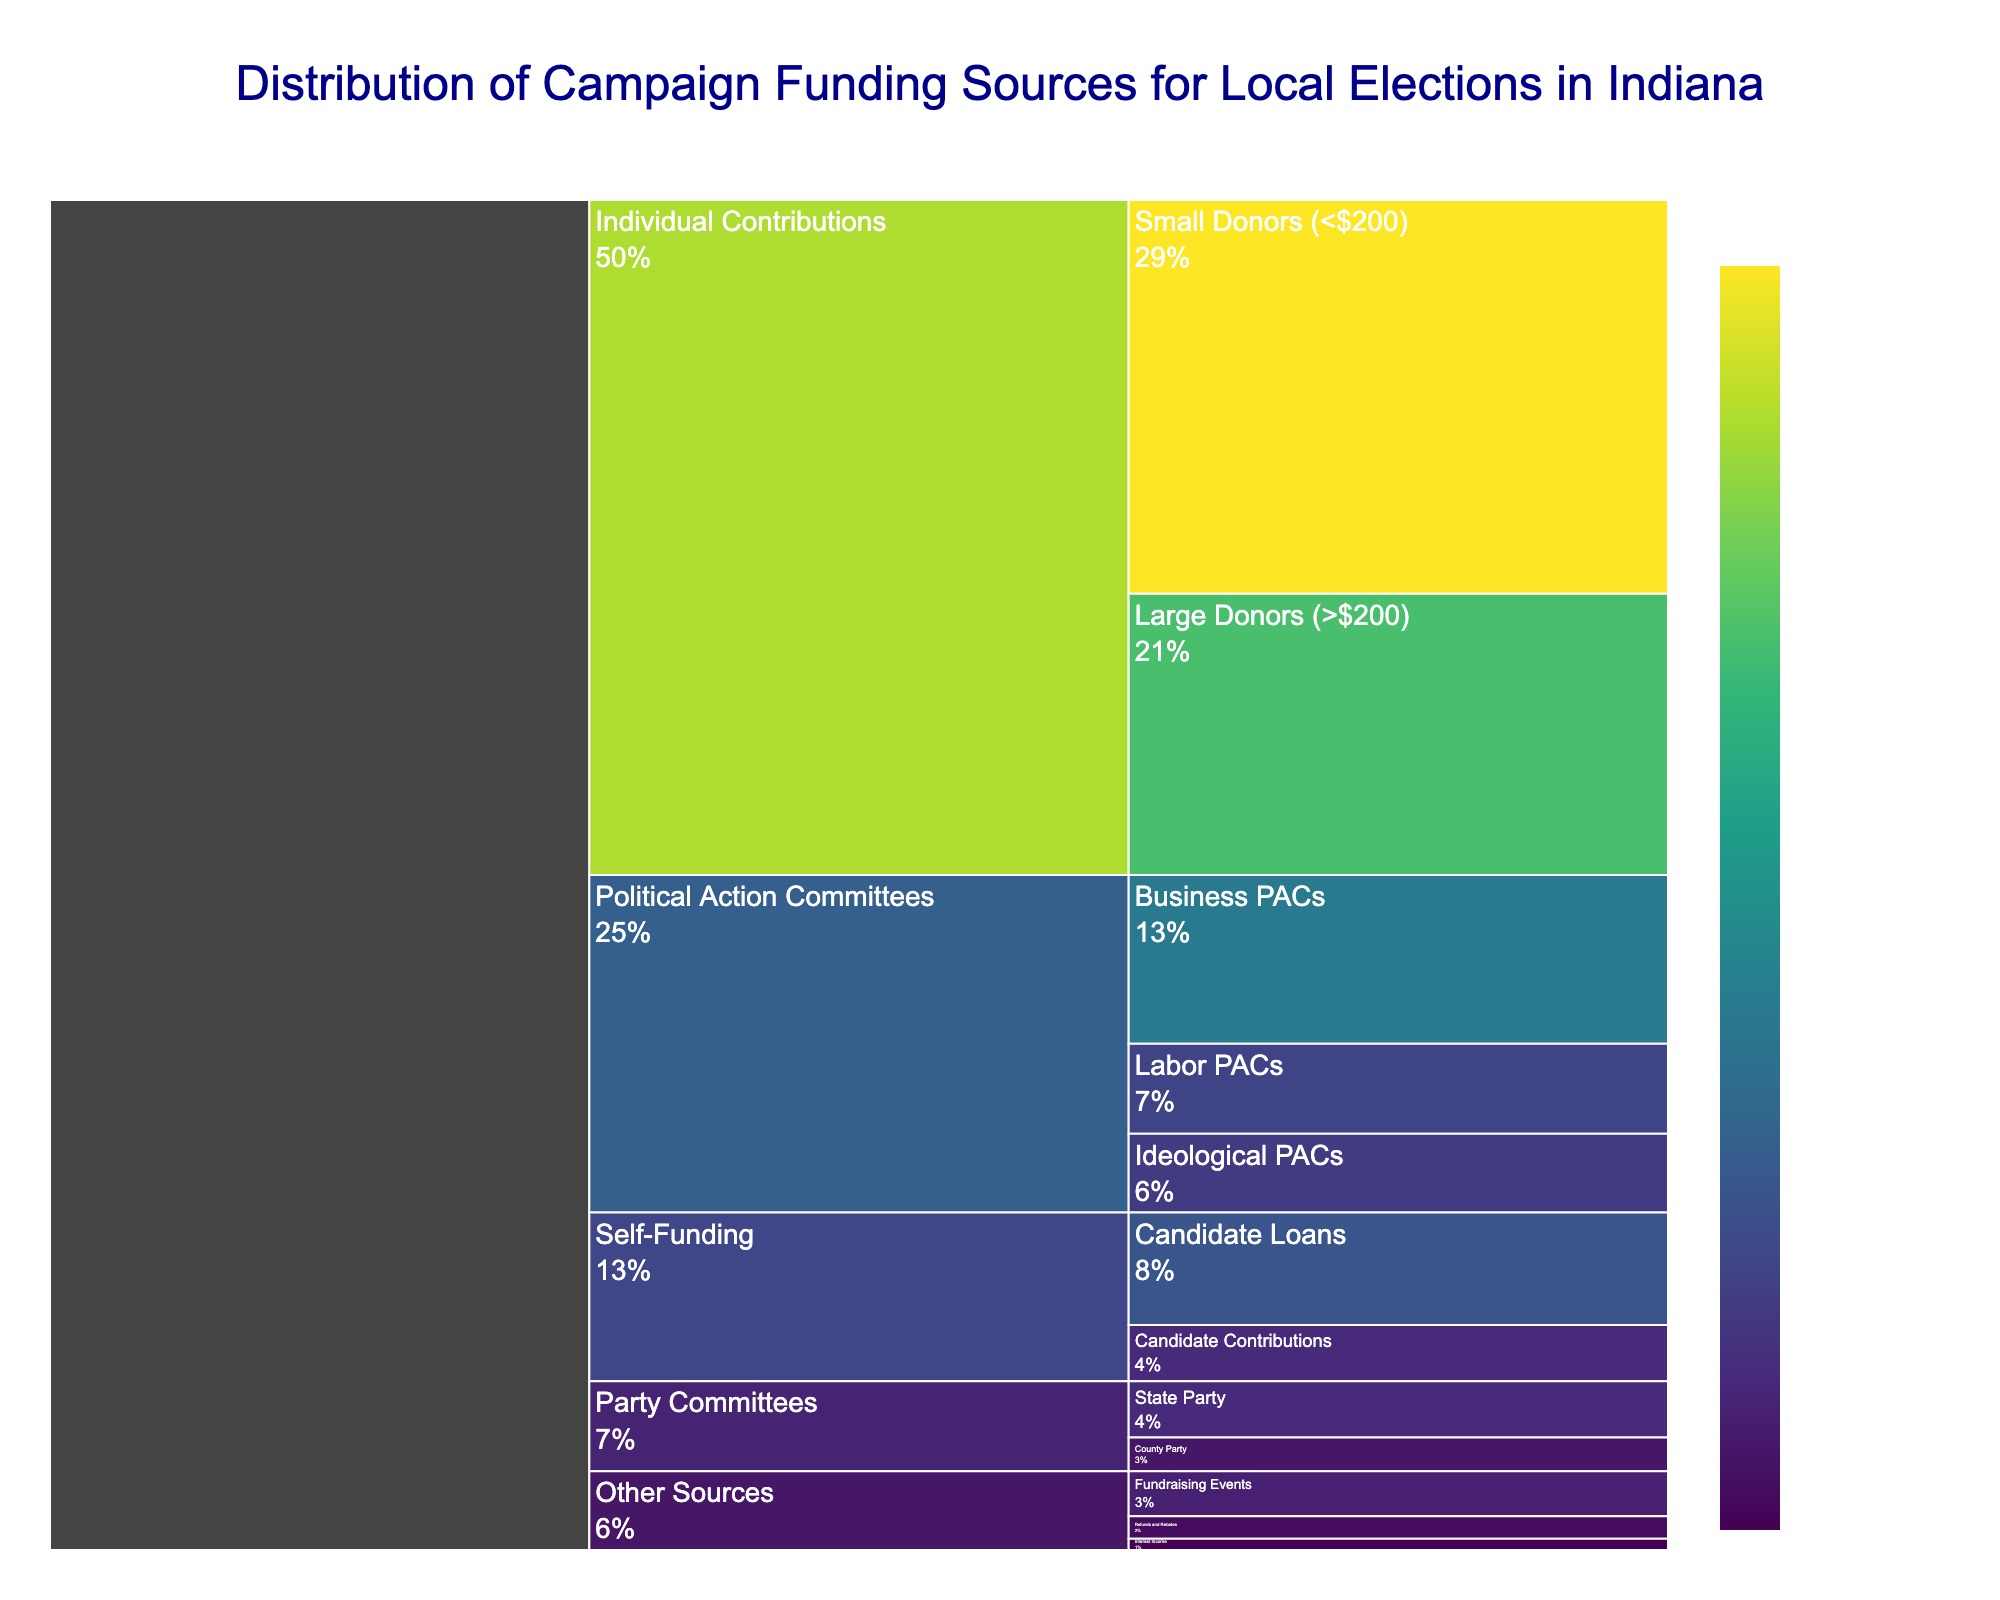What is the title of the icicle chart? The title of the chart is displayed prominently at the top of the figure in a large, dark blue font.
Answer: Distribution of Campaign Funding Sources for Local Elections in Indiana Which funding source category has the largest contribution value? By observing the sizes of the sections in the icicle chart, the category with the largest contribution value stands out.
Answer: Individual Contributions What is the combined contribution value of the Political Action Committees category? Sum the values of Business PACs (15), Labor PACs (8), and Ideological PACs (7) within the Political Action Committees category.
Answer: 30 Compare the contributions from Individual Contributions and Self-Funding categories. Which one is higher and by how much? Individual Contributions total 35 + 25 = 60, and Self-Funding totals 10 + 5 = 15. Subtract the Self-Funding value from the Individual Contributions value to find the difference. 60 - 15 = 45.
Answer: Individual Contributions is higher by 45 What percentage of the total funding does the State Party represent within the Party Committees category? First, sum the contributions under Party Committees (State Party: 5, County Party: 3, total=8). Then, calculate the percentage for State Party: (5 / 8) * 100 = 62.5%.
Answer: 62.5% Which subcategory within Other Sources has the smallest contribution value? Review the values of subcategories under Other Sources (Fundraising Events: 4, Interest Income: 1, Refunds and Rebates: 2) and identify the smallest value.
Answer: Interest Income What is the total contribution value from all categories combined? Sum the values of all the contributions across all categories. 35 + 25 + 15 + 8 + 7 + 5 + 3 + 10 + 5 + 4 + 1 + 2 = 120.
Answer: 120 How does the contribution from Large Donors compare to the total from all Political Action Committees? Large Donors value is 25. Total from all Political Action Committees is 30. Compare these two values by identifying that 25 (Large Donors) is less than 30 (Political Action Committees).
Answer: Large Donors' contribution is less by 5 What subcategories make up the Self-Funding category? Observe the subcategories presented in the icicle chart under the Self-Funding category.
Answer: Candidate Loans, Candidate Contributions Which category contributes most to the funding, excluding Individual Contributions? Remove Individual Contributions from consideration and sum the remaining categories. Political Action Committees is 30, Party Committees is 8, Self-Funding is 15, Other Sources is 7. The highest among these is Political Action Committees with 30.
Answer: Political Action Committees 